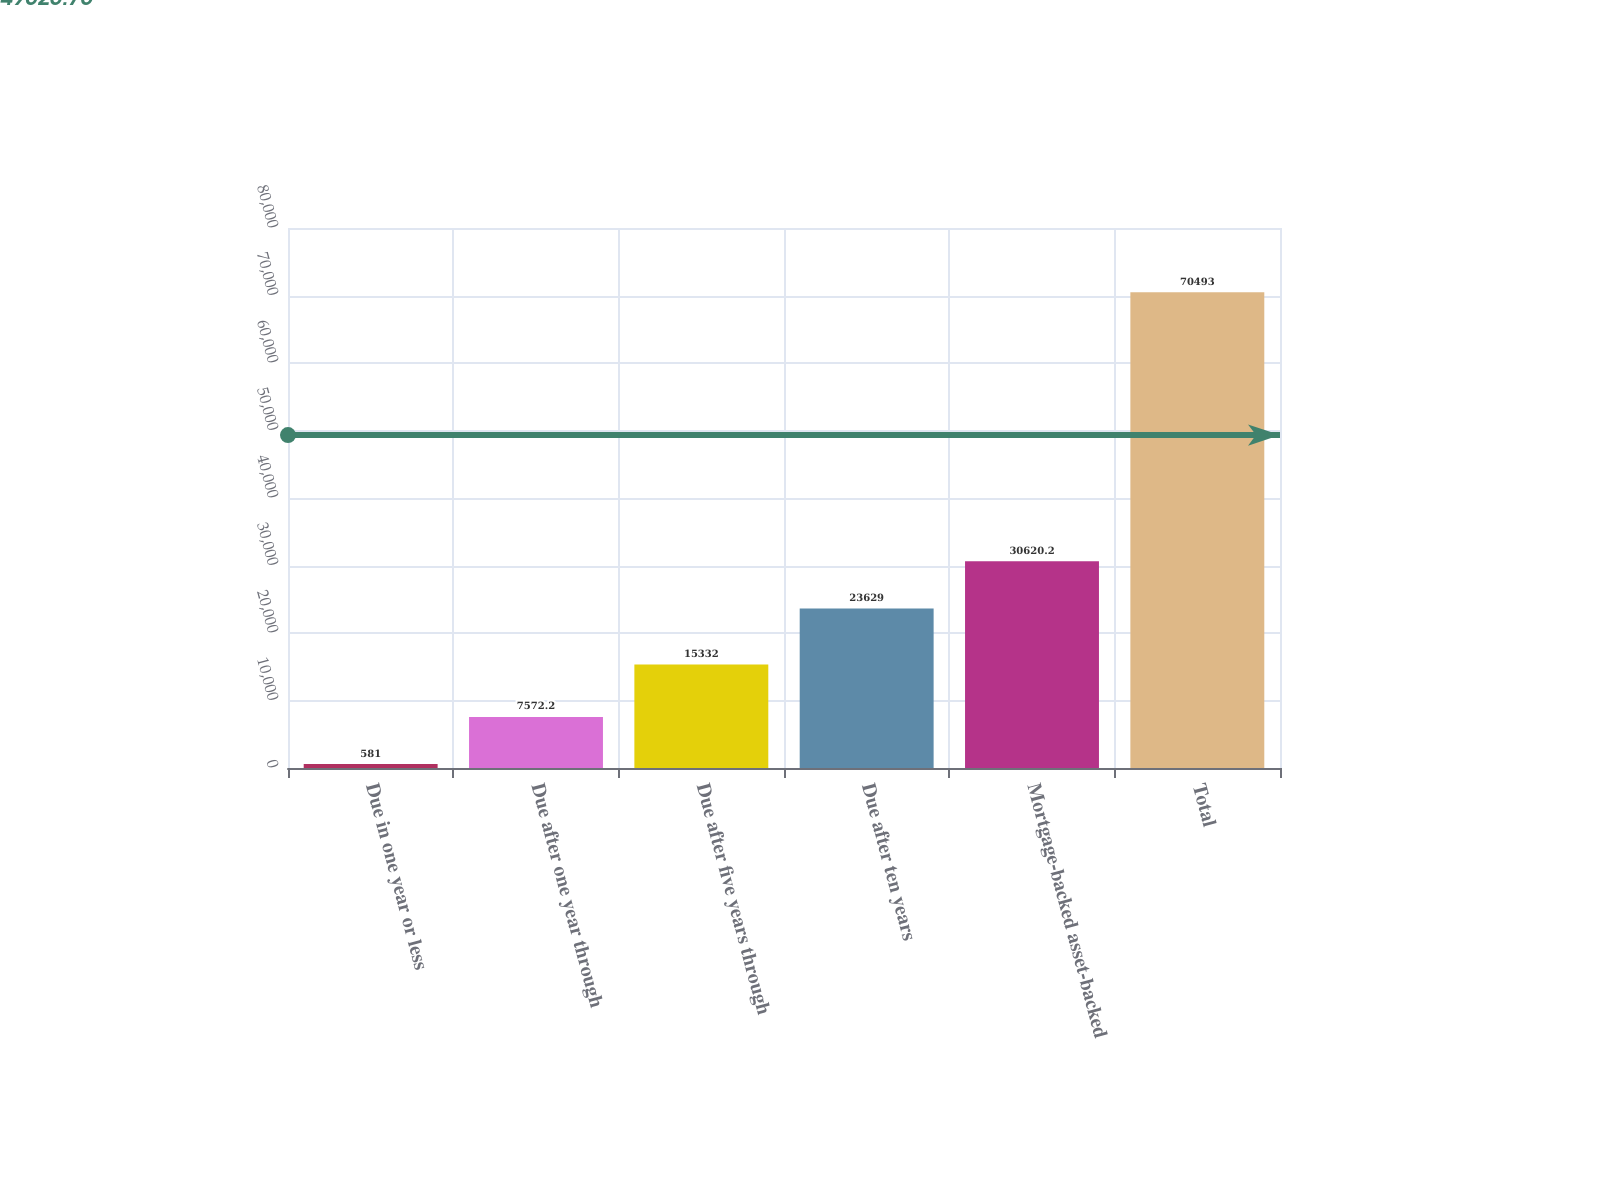Convert chart to OTSL. <chart><loc_0><loc_0><loc_500><loc_500><bar_chart><fcel>Due in one year or less<fcel>Due after one year through<fcel>Due after five years through<fcel>Due after ten years<fcel>Mortgage-backed asset-backed<fcel>Total<nl><fcel>581<fcel>7572.2<fcel>15332<fcel>23629<fcel>30620.2<fcel>70493<nl></chart> 